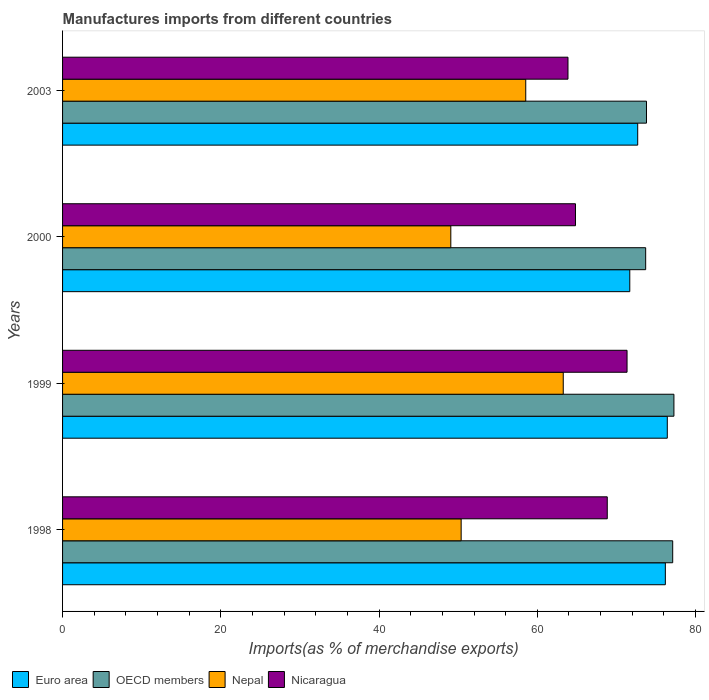How many different coloured bars are there?
Make the answer very short. 4. Are the number of bars per tick equal to the number of legend labels?
Ensure brevity in your answer.  Yes. How many bars are there on the 3rd tick from the bottom?
Your answer should be very brief. 4. What is the label of the 2nd group of bars from the top?
Your answer should be compact. 2000. What is the percentage of imports to different countries in Nicaragua in 2000?
Provide a short and direct response. 64.83. Across all years, what is the maximum percentage of imports to different countries in OECD members?
Give a very brief answer. 77.27. Across all years, what is the minimum percentage of imports to different countries in Nicaragua?
Your answer should be very brief. 63.88. In which year was the percentage of imports to different countries in Nicaragua minimum?
Your answer should be very brief. 2003. What is the total percentage of imports to different countries in OECD members in the graph?
Offer a terse response. 301.88. What is the difference between the percentage of imports to different countries in Nepal in 1998 and that in 1999?
Give a very brief answer. -12.9. What is the difference between the percentage of imports to different countries in OECD members in 2000 and the percentage of imports to different countries in Nicaragua in 2003?
Ensure brevity in your answer.  9.82. What is the average percentage of imports to different countries in OECD members per year?
Keep it short and to the point. 75.47. In the year 2003, what is the difference between the percentage of imports to different countries in Nepal and percentage of imports to different countries in Nicaragua?
Your response must be concise. -5.34. What is the ratio of the percentage of imports to different countries in Euro area in 1998 to that in 2003?
Give a very brief answer. 1.05. Is the difference between the percentage of imports to different countries in Nepal in 1999 and 2000 greater than the difference between the percentage of imports to different countries in Nicaragua in 1999 and 2000?
Ensure brevity in your answer.  Yes. What is the difference between the highest and the second highest percentage of imports to different countries in Nicaragua?
Offer a terse response. 2.5. What is the difference between the highest and the lowest percentage of imports to different countries in Euro area?
Provide a short and direct response. 4.74. What does the 1st bar from the top in 2000 represents?
Offer a terse response. Nicaragua. What does the 2nd bar from the bottom in 1998 represents?
Provide a succinct answer. OECD members. Are all the bars in the graph horizontal?
Offer a terse response. Yes. What is the difference between two consecutive major ticks on the X-axis?
Your answer should be compact. 20. How many legend labels are there?
Keep it short and to the point. 4. How are the legend labels stacked?
Your answer should be compact. Horizontal. What is the title of the graph?
Provide a succinct answer. Manufactures imports from different countries. Does "Spain" appear as one of the legend labels in the graph?
Keep it short and to the point. No. What is the label or title of the X-axis?
Offer a very short reply. Imports(as % of merchandise exports). What is the Imports(as % of merchandise exports) in Euro area in 1998?
Ensure brevity in your answer.  76.19. What is the Imports(as % of merchandise exports) of OECD members in 1998?
Make the answer very short. 77.11. What is the Imports(as % of merchandise exports) in Nepal in 1998?
Keep it short and to the point. 50.38. What is the Imports(as % of merchandise exports) of Nicaragua in 1998?
Give a very brief answer. 68.84. What is the Imports(as % of merchandise exports) in Euro area in 1999?
Your answer should be very brief. 76.43. What is the Imports(as % of merchandise exports) of OECD members in 1999?
Your answer should be very brief. 77.27. What is the Imports(as % of merchandise exports) in Nepal in 1999?
Give a very brief answer. 63.28. What is the Imports(as % of merchandise exports) in Nicaragua in 1999?
Provide a succinct answer. 71.34. What is the Imports(as % of merchandise exports) of Euro area in 2000?
Make the answer very short. 71.69. What is the Imports(as % of merchandise exports) in OECD members in 2000?
Ensure brevity in your answer.  73.7. What is the Imports(as % of merchandise exports) of Nepal in 2000?
Provide a succinct answer. 49.07. What is the Imports(as % of merchandise exports) of Nicaragua in 2000?
Ensure brevity in your answer.  64.83. What is the Imports(as % of merchandise exports) in Euro area in 2003?
Provide a succinct answer. 72.69. What is the Imports(as % of merchandise exports) of OECD members in 2003?
Your answer should be very brief. 73.8. What is the Imports(as % of merchandise exports) of Nepal in 2003?
Your answer should be very brief. 58.54. What is the Imports(as % of merchandise exports) of Nicaragua in 2003?
Ensure brevity in your answer.  63.88. Across all years, what is the maximum Imports(as % of merchandise exports) in Euro area?
Your answer should be very brief. 76.43. Across all years, what is the maximum Imports(as % of merchandise exports) in OECD members?
Provide a succinct answer. 77.27. Across all years, what is the maximum Imports(as % of merchandise exports) of Nepal?
Provide a succinct answer. 63.28. Across all years, what is the maximum Imports(as % of merchandise exports) of Nicaragua?
Your answer should be very brief. 71.34. Across all years, what is the minimum Imports(as % of merchandise exports) of Euro area?
Provide a succinct answer. 71.69. Across all years, what is the minimum Imports(as % of merchandise exports) in OECD members?
Your response must be concise. 73.7. Across all years, what is the minimum Imports(as % of merchandise exports) in Nepal?
Provide a short and direct response. 49.07. Across all years, what is the minimum Imports(as % of merchandise exports) of Nicaragua?
Your answer should be compact. 63.88. What is the total Imports(as % of merchandise exports) of Euro area in the graph?
Offer a terse response. 297. What is the total Imports(as % of merchandise exports) in OECD members in the graph?
Give a very brief answer. 301.88. What is the total Imports(as % of merchandise exports) in Nepal in the graph?
Your answer should be very brief. 221.27. What is the total Imports(as % of merchandise exports) in Nicaragua in the graph?
Keep it short and to the point. 268.9. What is the difference between the Imports(as % of merchandise exports) in Euro area in 1998 and that in 1999?
Your answer should be compact. -0.25. What is the difference between the Imports(as % of merchandise exports) in OECD members in 1998 and that in 1999?
Offer a very short reply. -0.15. What is the difference between the Imports(as % of merchandise exports) of Nepal in 1998 and that in 1999?
Make the answer very short. -12.9. What is the difference between the Imports(as % of merchandise exports) of Nicaragua in 1998 and that in 1999?
Offer a very short reply. -2.5. What is the difference between the Imports(as % of merchandise exports) of Euro area in 1998 and that in 2000?
Offer a terse response. 4.5. What is the difference between the Imports(as % of merchandise exports) in OECD members in 1998 and that in 2000?
Keep it short and to the point. 3.42. What is the difference between the Imports(as % of merchandise exports) of Nepal in 1998 and that in 2000?
Offer a terse response. 1.31. What is the difference between the Imports(as % of merchandise exports) in Nicaragua in 1998 and that in 2000?
Your answer should be compact. 4.02. What is the difference between the Imports(as % of merchandise exports) of Euro area in 1998 and that in 2003?
Your answer should be very brief. 3.49. What is the difference between the Imports(as % of merchandise exports) in OECD members in 1998 and that in 2003?
Your response must be concise. 3.31. What is the difference between the Imports(as % of merchandise exports) in Nepal in 1998 and that in 2003?
Your answer should be very brief. -8.16. What is the difference between the Imports(as % of merchandise exports) in Nicaragua in 1998 and that in 2003?
Provide a short and direct response. 4.96. What is the difference between the Imports(as % of merchandise exports) of Euro area in 1999 and that in 2000?
Give a very brief answer. 4.74. What is the difference between the Imports(as % of merchandise exports) of OECD members in 1999 and that in 2000?
Keep it short and to the point. 3.57. What is the difference between the Imports(as % of merchandise exports) of Nepal in 1999 and that in 2000?
Give a very brief answer. 14.21. What is the difference between the Imports(as % of merchandise exports) of Nicaragua in 1999 and that in 2000?
Provide a succinct answer. 6.52. What is the difference between the Imports(as % of merchandise exports) of Euro area in 1999 and that in 2003?
Keep it short and to the point. 3.74. What is the difference between the Imports(as % of merchandise exports) in OECD members in 1999 and that in 2003?
Offer a terse response. 3.47. What is the difference between the Imports(as % of merchandise exports) of Nepal in 1999 and that in 2003?
Your answer should be compact. 4.74. What is the difference between the Imports(as % of merchandise exports) in Nicaragua in 1999 and that in 2003?
Keep it short and to the point. 7.47. What is the difference between the Imports(as % of merchandise exports) of Euro area in 2000 and that in 2003?
Give a very brief answer. -1. What is the difference between the Imports(as % of merchandise exports) of OECD members in 2000 and that in 2003?
Make the answer very short. -0.1. What is the difference between the Imports(as % of merchandise exports) in Nepal in 2000 and that in 2003?
Your answer should be very brief. -9.47. What is the difference between the Imports(as % of merchandise exports) of Nicaragua in 2000 and that in 2003?
Offer a very short reply. 0.95. What is the difference between the Imports(as % of merchandise exports) in Euro area in 1998 and the Imports(as % of merchandise exports) in OECD members in 1999?
Your answer should be compact. -1.08. What is the difference between the Imports(as % of merchandise exports) of Euro area in 1998 and the Imports(as % of merchandise exports) of Nepal in 1999?
Your response must be concise. 12.9. What is the difference between the Imports(as % of merchandise exports) of Euro area in 1998 and the Imports(as % of merchandise exports) of Nicaragua in 1999?
Offer a very short reply. 4.84. What is the difference between the Imports(as % of merchandise exports) in OECD members in 1998 and the Imports(as % of merchandise exports) in Nepal in 1999?
Your response must be concise. 13.83. What is the difference between the Imports(as % of merchandise exports) of OECD members in 1998 and the Imports(as % of merchandise exports) of Nicaragua in 1999?
Offer a terse response. 5.77. What is the difference between the Imports(as % of merchandise exports) in Nepal in 1998 and the Imports(as % of merchandise exports) in Nicaragua in 1999?
Your response must be concise. -20.97. What is the difference between the Imports(as % of merchandise exports) in Euro area in 1998 and the Imports(as % of merchandise exports) in OECD members in 2000?
Your answer should be very brief. 2.49. What is the difference between the Imports(as % of merchandise exports) of Euro area in 1998 and the Imports(as % of merchandise exports) of Nepal in 2000?
Ensure brevity in your answer.  27.12. What is the difference between the Imports(as % of merchandise exports) in Euro area in 1998 and the Imports(as % of merchandise exports) in Nicaragua in 2000?
Your answer should be compact. 11.36. What is the difference between the Imports(as % of merchandise exports) of OECD members in 1998 and the Imports(as % of merchandise exports) of Nepal in 2000?
Make the answer very short. 28.04. What is the difference between the Imports(as % of merchandise exports) in OECD members in 1998 and the Imports(as % of merchandise exports) in Nicaragua in 2000?
Make the answer very short. 12.29. What is the difference between the Imports(as % of merchandise exports) of Nepal in 1998 and the Imports(as % of merchandise exports) of Nicaragua in 2000?
Offer a terse response. -14.45. What is the difference between the Imports(as % of merchandise exports) of Euro area in 1998 and the Imports(as % of merchandise exports) of OECD members in 2003?
Make the answer very short. 2.38. What is the difference between the Imports(as % of merchandise exports) in Euro area in 1998 and the Imports(as % of merchandise exports) in Nepal in 2003?
Your answer should be very brief. 17.64. What is the difference between the Imports(as % of merchandise exports) of Euro area in 1998 and the Imports(as % of merchandise exports) of Nicaragua in 2003?
Give a very brief answer. 12.31. What is the difference between the Imports(as % of merchandise exports) of OECD members in 1998 and the Imports(as % of merchandise exports) of Nepal in 2003?
Offer a very short reply. 18.57. What is the difference between the Imports(as % of merchandise exports) of OECD members in 1998 and the Imports(as % of merchandise exports) of Nicaragua in 2003?
Your answer should be compact. 13.23. What is the difference between the Imports(as % of merchandise exports) in Nepal in 1998 and the Imports(as % of merchandise exports) in Nicaragua in 2003?
Make the answer very short. -13.5. What is the difference between the Imports(as % of merchandise exports) of Euro area in 1999 and the Imports(as % of merchandise exports) of OECD members in 2000?
Give a very brief answer. 2.73. What is the difference between the Imports(as % of merchandise exports) in Euro area in 1999 and the Imports(as % of merchandise exports) in Nepal in 2000?
Keep it short and to the point. 27.36. What is the difference between the Imports(as % of merchandise exports) of Euro area in 1999 and the Imports(as % of merchandise exports) of Nicaragua in 2000?
Offer a terse response. 11.6. What is the difference between the Imports(as % of merchandise exports) of OECD members in 1999 and the Imports(as % of merchandise exports) of Nepal in 2000?
Ensure brevity in your answer.  28.2. What is the difference between the Imports(as % of merchandise exports) of OECD members in 1999 and the Imports(as % of merchandise exports) of Nicaragua in 2000?
Keep it short and to the point. 12.44. What is the difference between the Imports(as % of merchandise exports) in Nepal in 1999 and the Imports(as % of merchandise exports) in Nicaragua in 2000?
Your answer should be very brief. -1.55. What is the difference between the Imports(as % of merchandise exports) of Euro area in 1999 and the Imports(as % of merchandise exports) of OECD members in 2003?
Provide a succinct answer. 2.63. What is the difference between the Imports(as % of merchandise exports) of Euro area in 1999 and the Imports(as % of merchandise exports) of Nepal in 2003?
Keep it short and to the point. 17.89. What is the difference between the Imports(as % of merchandise exports) of Euro area in 1999 and the Imports(as % of merchandise exports) of Nicaragua in 2003?
Offer a terse response. 12.55. What is the difference between the Imports(as % of merchandise exports) of OECD members in 1999 and the Imports(as % of merchandise exports) of Nepal in 2003?
Keep it short and to the point. 18.73. What is the difference between the Imports(as % of merchandise exports) of OECD members in 1999 and the Imports(as % of merchandise exports) of Nicaragua in 2003?
Your answer should be compact. 13.39. What is the difference between the Imports(as % of merchandise exports) in Nepal in 1999 and the Imports(as % of merchandise exports) in Nicaragua in 2003?
Your response must be concise. -0.6. What is the difference between the Imports(as % of merchandise exports) in Euro area in 2000 and the Imports(as % of merchandise exports) in OECD members in 2003?
Offer a terse response. -2.11. What is the difference between the Imports(as % of merchandise exports) in Euro area in 2000 and the Imports(as % of merchandise exports) in Nepal in 2003?
Keep it short and to the point. 13.15. What is the difference between the Imports(as % of merchandise exports) in Euro area in 2000 and the Imports(as % of merchandise exports) in Nicaragua in 2003?
Ensure brevity in your answer.  7.81. What is the difference between the Imports(as % of merchandise exports) of OECD members in 2000 and the Imports(as % of merchandise exports) of Nepal in 2003?
Give a very brief answer. 15.16. What is the difference between the Imports(as % of merchandise exports) of OECD members in 2000 and the Imports(as % of merchandise exports) of Nicaragua in 2003?
Your response must be concise. 9.82. What is the difference between the Imports(as % of merchandise exports) in Nepal in 2000 and the Imports(as % of merchandise exports) in Nicaragua in 2003?
Ensure brevity in your answer.  -14.81. What is the average Imports(as % of merchandise exports) of Euro area per year?
Your answer should be compact. 74.25. What is the average Imports(as % of merchandise exports) in OECD members per year?
Make the answer very short. 75.47. What is the average Imports(as % of merchandise exports) in Nepal per year?
Give a very brief answer. 55.32. What is the average Imports(as % of merchandise exports) in Nicaragua per year?
Provide a succinct answer. 67.22. In the year 1998, what is the difference between the Imports(as % of merchandise exports) in Euro area and Imports(as % of merchandise exports) in OECD members?
Your answer should be very brief. -0.93. In the year 1998, what is the difference between the Imports(as % of merchandise exports) in Euro area and Imports(as % of merchandise exports) in Nepal?
Make the answer very short. 25.81. In the year 1998, what is the difference between the Imports(as % of merchandise exports) of Euro area and Imports(as % of merchandise exports) of Nicaragua?
Ensure brevity in your answer.  7.34. In the year 1998, what is the difference between the Imports(as % of merchandise exports) in OECD members and Imports(as % of merchandise exports) in Nepal?
Make the answer very short. 26.74. In the year 1998, what is the difference between the Imports(as % of merchandise exports) in OECD members and Imports(as % of merchandise exports) in Nicaragua?
Your answer should be very brief. 8.27. In the year 1998, what is the difference between the Imports(as % of merchandise exports) in Nepal and Imports(as % of merchandise exports) in Nicaragua?
Ensure brevity in your answer.  -18.47. In the year 1999, what is the difference between the Imports(as % of merchandise exports) in Euro area and Imports(as % of merchandise exports) in OECD members?
Ensure brevity in your answer.  -0.84. In the year 1999, what is the difference between the Imports(as % of merchandise exports) of Euro area and Imports(as % of merchandise exports) of Nepal?
Ensure brevity in your answer.  13.15. In the year 1999, what is the difference between the Imports(as % of merchandise exports) of Euro area and Imports(as % of merchandise exports) of Nicaragua?
Your answer should be compact. 5.09. In the year 1999, what is the difference between the Imports(as % of merchandise exports) in OECD members and Imports(as % of merchandise exports) in Nepal?
Ensure brevity in your answer.  13.99. In the year 1999, what is the difference between the Imports(as % of merchandise exports) in OECD members and Imports(as % of merchandise exports) in Nicaragua?
Make the answer very short. 5.92. In the year 1999, what is the difference between the Imports(as % of merchandise exports) of Nepal and Imports(as % of merchandise exports) of Nicaragua?
Your answer should be compact. -8.06. In the year 2000, what is the difference between the Imports(as % of merchandise exports) in Euro area and Imports(as % of merchandise exports) in OECD members?
Offer a very short reply. -2.01. In the year 2000, what is the difference between the Imports(as % of merchandise exports) of Euro area and Imports(as % of merchandise exports) of Nepal?
Provide a short and direct response. 22.62. In the year 2000, what is the difference between the Imports(as % of merchandise exports) of Euro area and Imports(as % of merchandise exports) of Nicaragua?
Provide a short and direct response. 6.86. In the year 2000, what is the difference between the Imports(as % of merchandise exports) in OECD members and Imports(as % of merchandise exports) in Nepal?
Offer a terse response. 24.63. In the year 2000, what is the difference between the Imports(as % of merchandise exports) of OECD members and Imports(as % of merchandise exports) of Nicaragua?
Offer a very short reply. 8.87. In the year 2000, what is the difference between the Imports(as % of merchandise exports) in Nepal and Imports(as % of merchandise exports) in Nicaragua?
Make the answer very short. -15.76. In the year 2003, what is the difference between the Imports(as % of merchandise exports) of Euro area and Imports(as % of merchandise exports) of OECD members?
Your answer should be compact. -1.11. In the year 2003, what is the difference between the Imports(as % of merchandise exports) in Euro area and Imports(as % of merchandise exports) in Nepal?
Your response must be concise. 14.15. In the year 2003, what is the difference between the Imports(as % of merchandise exports) of Euro area and Imports(as % of merchandise exports) of Nicaragua?
Your answer should be compact. 8.81. In the year 2003, what is the difference between the Imports(as % of merchandise exports) in OECD members and Imports(as % of merchandise exports) in Nepal?
Your response must be concise. 15.26. In the year 2003, what is the difference between the Imports(as % of merchandise exports) of OECD members and Imports(as % of merchandise exports) of Nicaragua?
Provide a succinct answer. 9.92. In the year 2003, what is the difference between the Imports(as % of merchandise exports) of Nepal and Imports(as % of merchandise exports) of Nicaragua?
Provide a succinct answer. -5.34. What is the ratio of the Imports(as % of merchandise exports) of OECD members in 1998 to that in 1999?
Your response must be concise. 1. What is the ratio of the Imports(as % of merchandise exports) in Nepal in 1998 to that in 1999?
Offer a terse response. 0.8. What is the ratio of the Imports(as % of merchandise exports) in Nicaragua in 1998 to that in 1999?
Give a very brief answer. 0.96. What is the ratio of the Imports(as % of merchandise exports) of Euro area in 1998 to that in 2000?
Make the answer very short. 1.06. What is the ratio of the Imports(as % of merchandise exports) in OECD members in 1998 to that in 2000?
Give a very brief answer. 1.05. What is the ratio of the Imports(as % of merchandise exports) of Nepal in 1998 to that in 2000?
Offer a terse response. 1.03. What is the ratio of the Imports(as % of merchandise exports) in Nicaragua in 1998 to that in 2000?
Your answer should be compact. 1.06. What is the ratio of the Imports(as % of merchandise exports) of Euro area in 1998 to that in 2003?
Offer a terse response. 1.05. What is the ratio of the Imports(as % of merchandise exports) of OECD members in 1998 to that in 2003?
Keep it short and to the point. 1.04. What is the ratio of the Imports(as % of merchandise exports) in Nepal in 1998 to that in 2003?
Make the answer very short. 0.86. What is the ratio of the Imports(as % of merchandise exports) of Nicaragua in 1998 to that in 2003?
Provide a short and direct response. 1.08. What is the ratio of the Imports(as % of merchandise exports) of Euro area in 1999 to that in 2000?
Your response must be concise. 1.07. What is the ratio of the Imports(as % of merchandise exports) in OECD members in 1999 to that in 2000?
Offer a terse response. 1.05. What is the ratio of the Imports(as % of merchandise exports) in Nepal in 1999 to that in 2000?
Keep it short and to the point. 1.29. What is the ratio of the Imports(as % of merchandise exports) of Nicaragua in 1999 to that in 2000?
Your answer should be very brief. 1.1. What is the ratio of the Imports(as % of merchandise exports) in Euro area in 1999 to that in 2003?
Provide a succinct answer. 1.05. What is the ratio of the Imports(as % of merchandise exports) in OECD members in 1999 to that in 2003?
Provide a succinct answer. 1.05. What is the ratio of the Imports(as % of merchandise exports) in Nepal in 1999 to that in 2003?
Offer a terse response. 1.08. What is the ratio of the Imports(as % of merchandise exports) in Nicaragua in 1999 to that in 2003?
Make the answer very short. 1.12. What is the ratio of the Imports(as % of merchandise exports) in Euro area in 2000 to that in 2003?
Make the answer very short. 0.99. What is the ratio of the Imports(as % of merchandise exports) in OECD members in 2000 to that in 2003?
Your answer should be compact. 1. What is the ratio of the Imports(as % of merchandise exports) in Nepal in 2000 to that in 2003?
Make the answer very short. 0.84. What is the ratio of the Imports(as % of merchandise exports) in Nicaragua in 2000 to that in 2003?
Your answer should be very brief. 1.01. What is the difference between the highest and the second highest Imports(as % of merchandise exports) of Euro area?
Ensure brevity in your answer.  0.25. What is the difference between the highest and the second highest Imports(as % of merchandise exports) in OECD members?
Keep it short and to the point. 0.15. What is the difference between the highest and the second highest Imports(as % of merchandise exports) in Nepal?
Offer a very short reply. 4.74. What is the difference between the highest and the second highest Imports(as % of merchandise exports) of Nicaragua?
Ensure brevity in your answer.  2.5. What is the difference between the highest and the lowest Imports(as % of merchandise exports) in Euro area?
Provide a short and direct response. 4.74. What is the difference between the highest and the lowest Imports(as % of merchandise exports) of OECD members?
Your response must be concise. 3.57. What is the difference between the highest and the lowest Imports(as % of merchandise exports) in Nepal?
Provide a succinct answer. 14.21. What is the difference between the highest and the lowest Imports(as % of merchandise exports) of Nicaragua?
Your answer should be very brief. 7.47. 